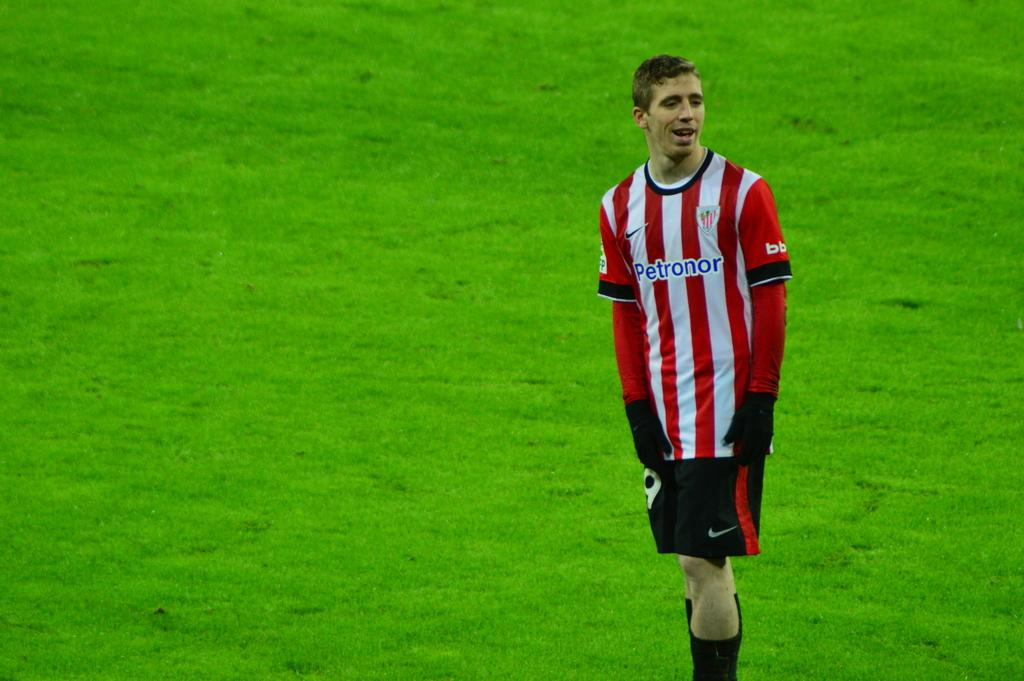<image>
Provide a brief description of the given image. a person with a jersey that says Petronor on it 